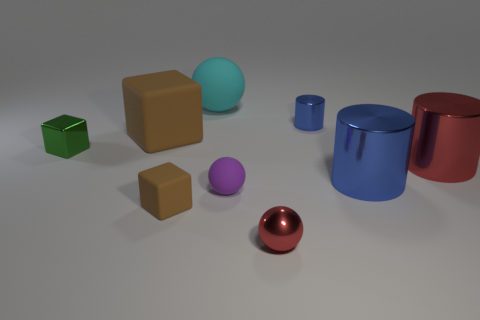What number of objects are both behind the small matte cube and in front of the large cyan rubber thing? Upon examining the image, considering the perspective and relative positions, it appears there are three objects situated behind the small green cube and in front of the large blue cylinder. These are a small purple sphere, a medium tan cube, and a small red sphere. 